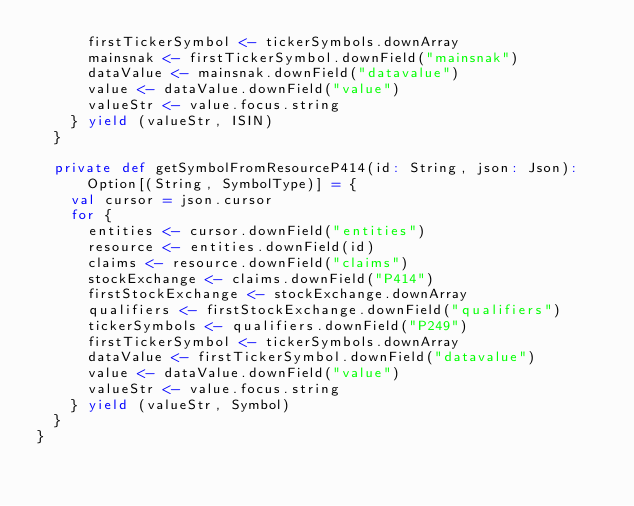<code> <loc_0><loc_0><loc_500><loc_500><_Scala_>      firstTickerSymbol <- tickerSymbols.downArray
      mainsnak <- firstTickerSymbol.downField("mainsnak")
      dataValue <- mainsnak.downField("datavalue")
      value <- dataValue.downField("value")
      valueStr <- value.focus.string
    } yield (valueStr, ISIN)
  }

  private def getSymbolFromResourceP414(id: String, json: Json): Option[(String, SymbolType)] = {
    val cursor = json.cursor
    for {
      entities <- cursor.downField("entities")
      resource <- entities.downField(id)
      claims <- resource.downField("claims")
      stockExchange <- claims.downField("P414")
      firstStockExchange <- stockExchange.downArray
      qualifiers <- firstStockExchange.downField("qualifiers")
      tickerSymbols <- qualifiers.downField("P249")
      firstTickerSymbol <- tickerSymbols.downArray
      dataValue <- firstTickerSymbol.downField("datavalue")
      value <- dataValue.downField("value")
      valueStr <- value.focus.string
    } yield (valueStr, Symbol)
  }
}
</code> 